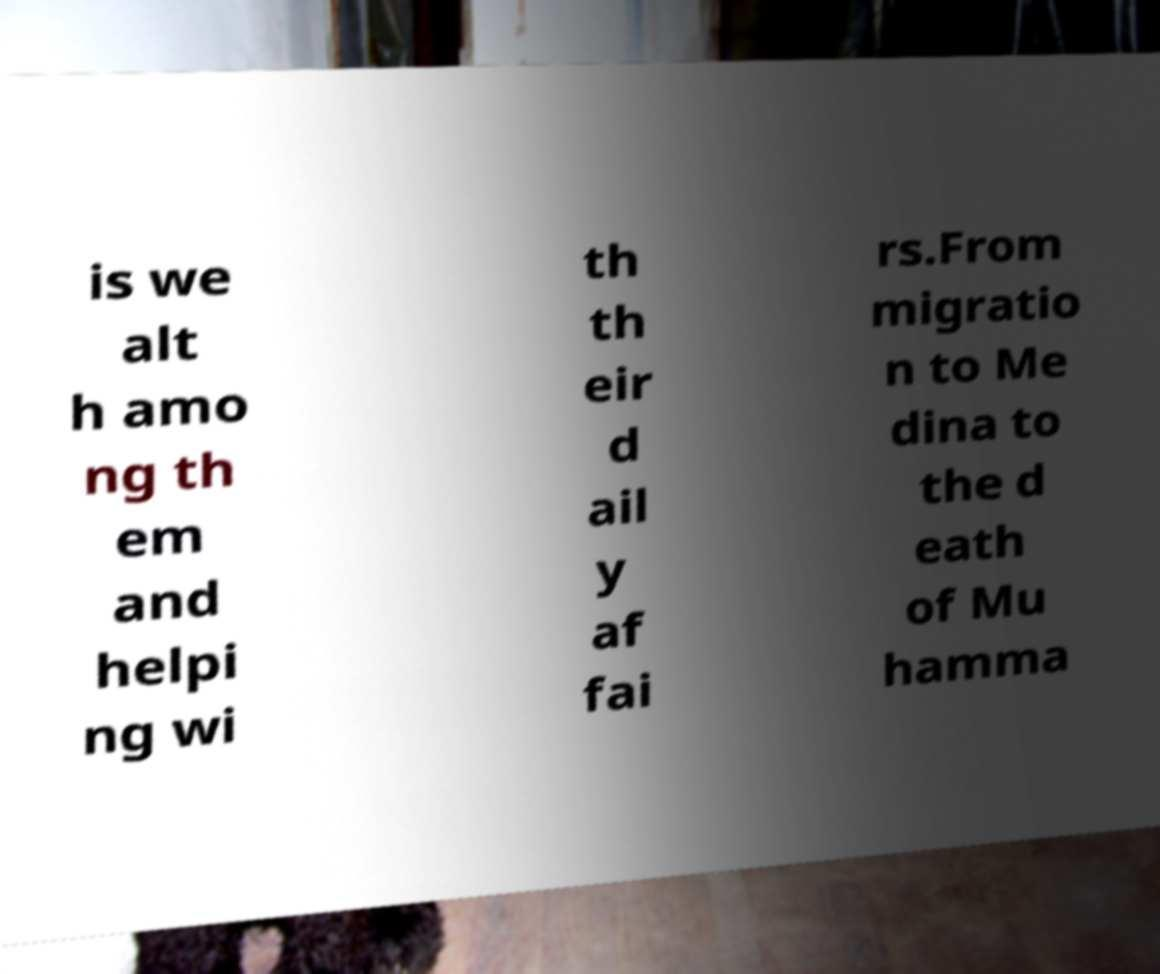There's text embedded in this image that I need extracted. Can you transcribe it verbatim? is we alt h amo ng th em and helpi ng wi th th eir d ail y af fai rs.From migratio n to Me dina to the d eath of Mu hamma 